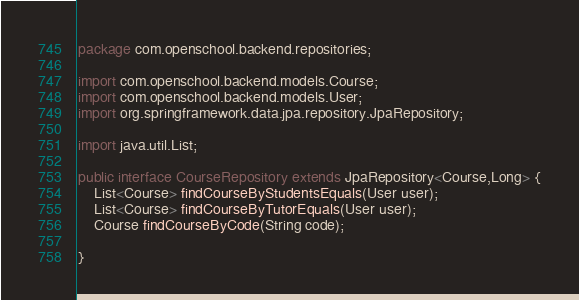Convert code to text. <code><loc_0><loc_0><loc_500><loc_500><_Java_>package com.openschool.backend.repositories;

import com.openschool.backend.models.Course;
import com.openschool.backend.models.User;
import org.springframework.data.jpa.repository.JpaRepository;

import java.util.List;

public interface CourseRepository extends JpaRepository<Course,Long> {
    List<Course> findCourseByStudentsEquals(User user);
    List<Course> findCourseByTutorEquals(User user);
    Course findCourseByCode(String code);

}
</code> 